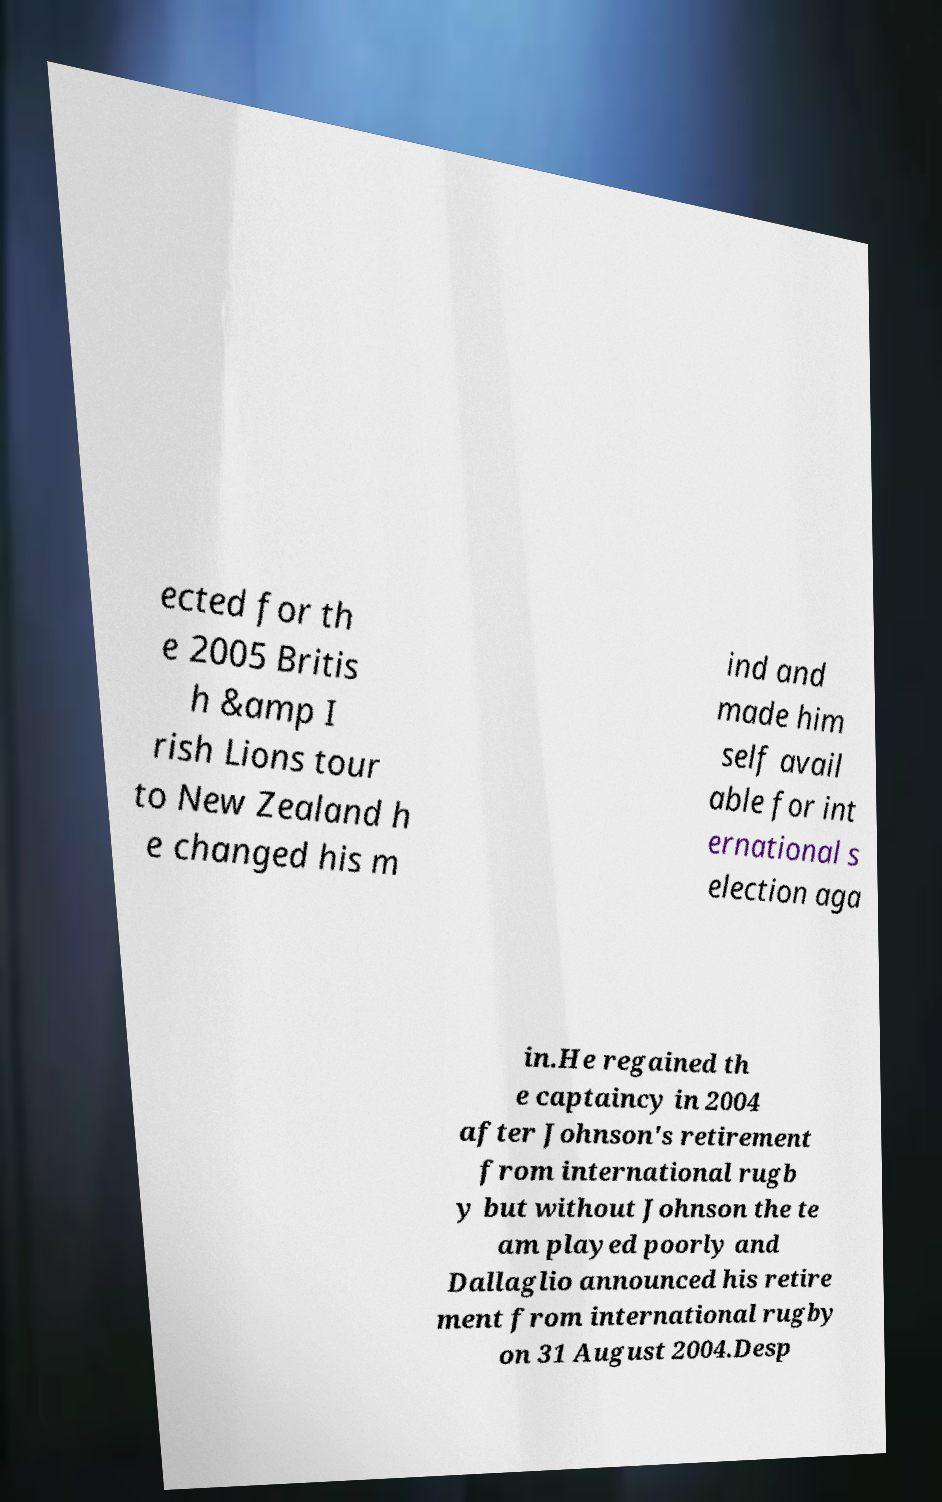Could you extract and type out the text from this image? ected for th e 2005 Britis h &amp I rish Lions tour to New Zealand h e changed his m ind and made him self avail able for int ernational s election aga in.He regained th e captaincy in 2004 after Johnson's retirement from international rugb y but without Johnson the te am played poorly and Dallaglio announced his retire ment from international rugby on 31 August 2004.Desp 